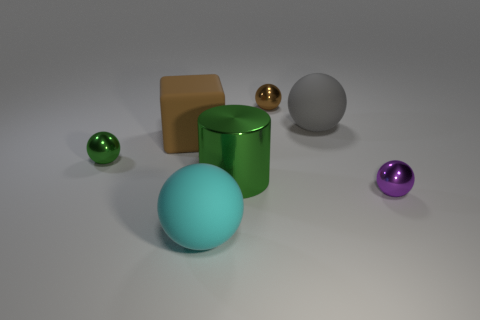What number of other things are there of the same color as the large rubber cube?
Provide a short and direct response. 1. Are there fewer big brown objects that are behind the small brown shiny ball than large cyan things that are behind the gray matte sphere?
Provide a short and direct response. No. How many things are either tiny metal objects that are to the left of the tiny brown thing or brown shiny balls?
Make the answer very short. 2. Do the purple sphere and the green object that is to the left of the large brown block have the same size?
Your answer should be very brief. Yes. What is the size of the brown thing that is the same shape as the purple metal object?
Provide a succinct answer. Small. There is a tiny brown metal ball to the right of the large sphere in front of the rubber cube; how many metal balls are on the left side of it?
Ensure brevity in your answer.  1. How many spheres are large gray objects or green objects?
Offer a terse response. 2. There is a large rubber ball in front of the rubber object on the right side of the large rubber ball that is in front of the small green shiny sphere; what is its color?
Offer a terse response. Cyan. What number of other things are the same size as the green shiny cylinder?
Provide a succinct answer. 3. Is there anything else that has the same shape as the small brown shiny thing?
Your answer should be very brief. Yes. 